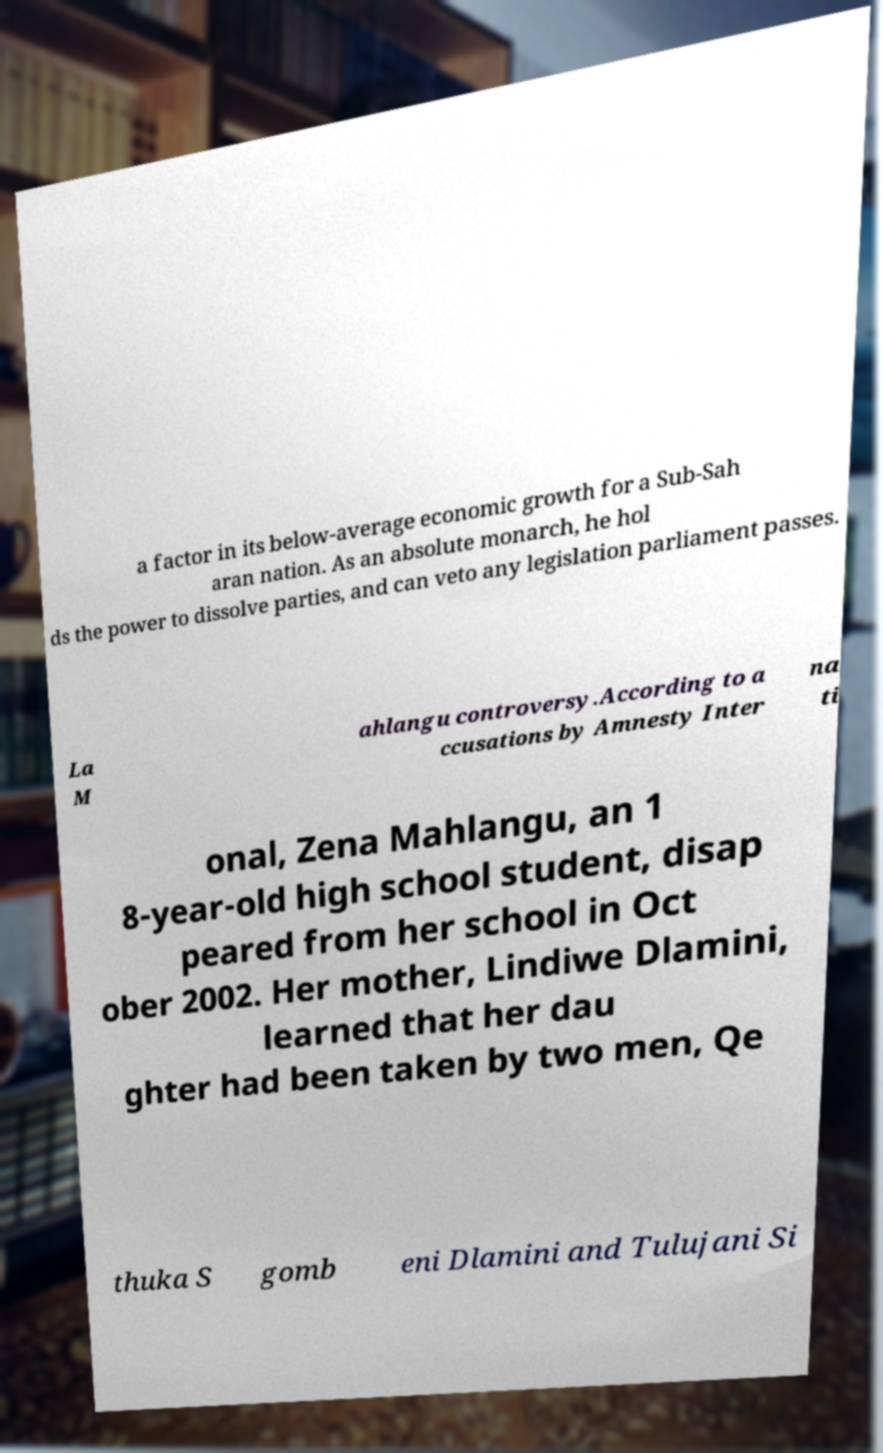I need the written content from this picture converted into text. Can you do that? a factor in its below-average economic growth for a Sub-Sah aran nation. As an absolute monarch, he hol ds the power to dissolve parties, and can veto any legislation parliament passes. La M ahlangu controversy.According to a ccusations by Amnesty Inter na ti onal, Zena Mahlangu, an 1 8-year-old high school student, disap peared from her school in Oct ober 2002. Her mother, Lindiwe Dlamini, learned that her dau ghter had been taken by two men, Qe thuka S gomb eni Dlamini and Tulujani Si 